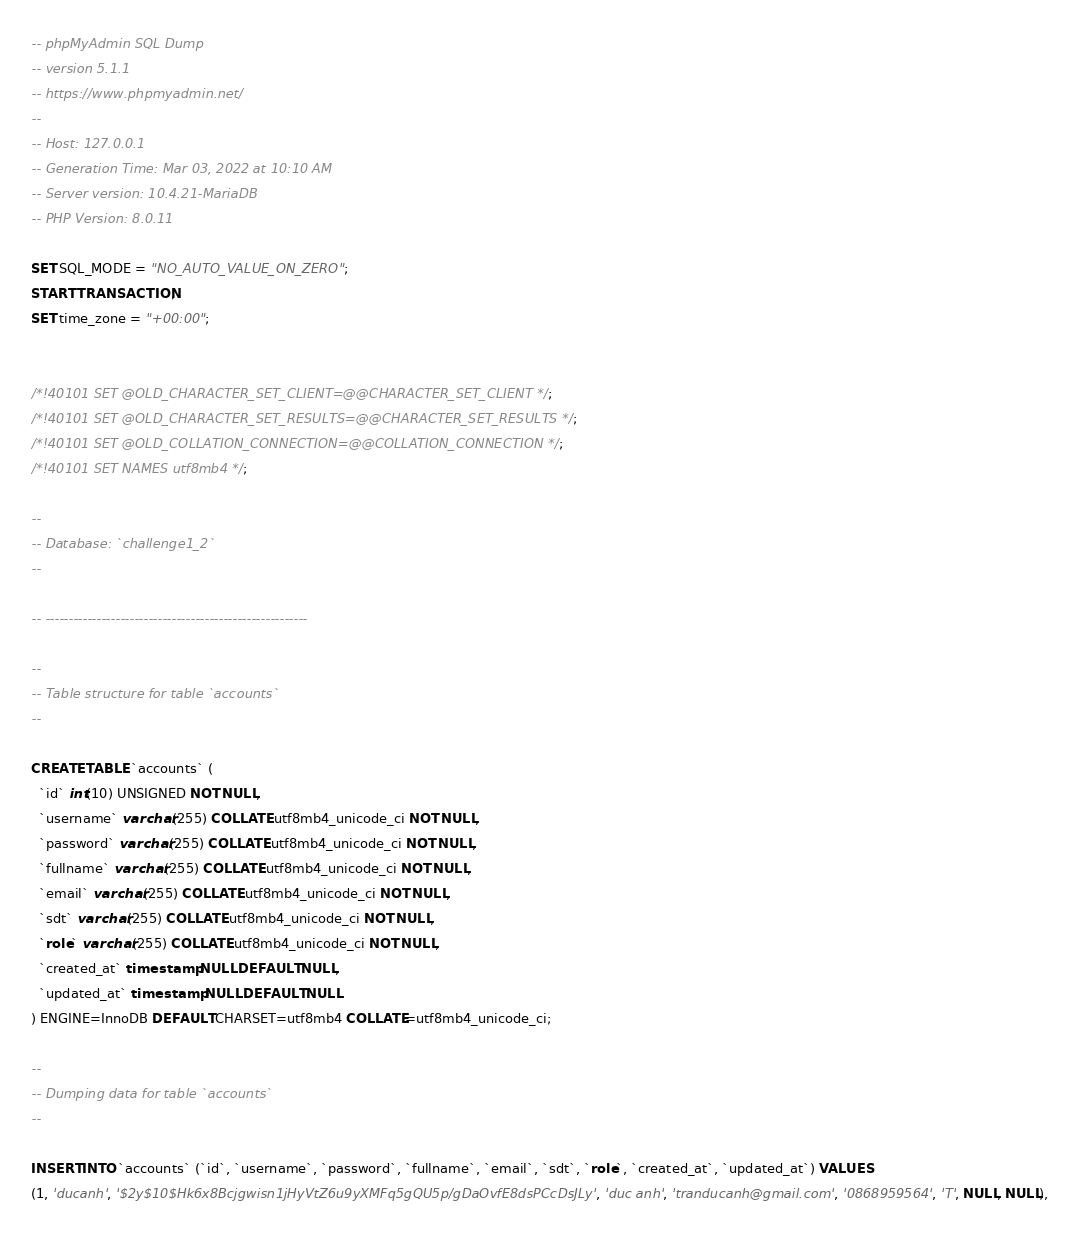Convert code to text. <code><loc_0><loc_0><loc_500><loc_500><_SQL_>-- phpMyAdmin SQL Dump
-- version 5.1.1
-- https://www.phpmyadmin.net/
--
-- Host: 127.0.0.1
-- Generation Time: Mar 03, 2022 at 10:10 AM
-- Server version: 10.4.21-MariaDB
-- PHP Version: 8.0.11

SET SQL_MODE = "NO_AUTO_VALUE_ON_ZERO";
START TRANSACTION;
SET time_zone = "+00:00";


/*!40101 SET @OLD_CHARACTER_SET_CLIENT=@@CHARACTER_SET_CLIENT */;
/*!40101 SET @OLD_CHARACTER_SET_RESULTS=@@CHARACTER_SET_RESULTS */;
/*!40101 SET @OLD_COLLATION_CONNECTION=@@COLLATION_CONNECTION */;
/*!40101 SET NAMES utf8mb4 */;

--
-- Database: `challenge1_2`
--

-- --------------------------------------------------------

--
-- Table structure for table `accounts`
--

CREATE TABLE `accounts` (
  `id` int(10) UNSIGNED NOT NULL,
  `username` varchar(255) COLLATE utf8mb4_unicode_ci NOT NULL,
  `password` varchar(255) COLLATE utf8mb4_unicode_ci NOT NULL,
  `fullname` varchar(255) COLLATE utf8mb4_unicode_ci NOT NULL,
  `email` varchar(255) COLLATE utf8mb4_unicode_ci NOT NULL,
  `sdt` varchar(255) COLLATE utf8mb4_unicode_ci NOT NULL,
  `role` varchar(255) COLLATE utf8mb4_unicode_ci NOT NULL,
  `created_at` timestamp NULL DEFAULT NULL,
  `updated_at` timestamp NULL DEFAULT NULL
) ENGINE=InnoDB DEFAULT CHARSET=utf8mb4 COLLATE=utf8mb4_unicode_ci;

--
-- Dumping data for table `accounts`
--

INSERT INTO `accounts` (`id`, `username`, `password`, `fullname`, `email`, `sdt`, `role`, `created_at`, `updated_at`) VALUES
(1, 'ducanh', '$2y$10$Hk6x8Bcjgwisn1jHyVtZ6u9yXMFq5gQU5p/gDaOvfE8dsPCcDsJLy', 'duc anh', 'tranducanh@gmail.com', '0868959564', 'T', NULL, NULL),</code> 